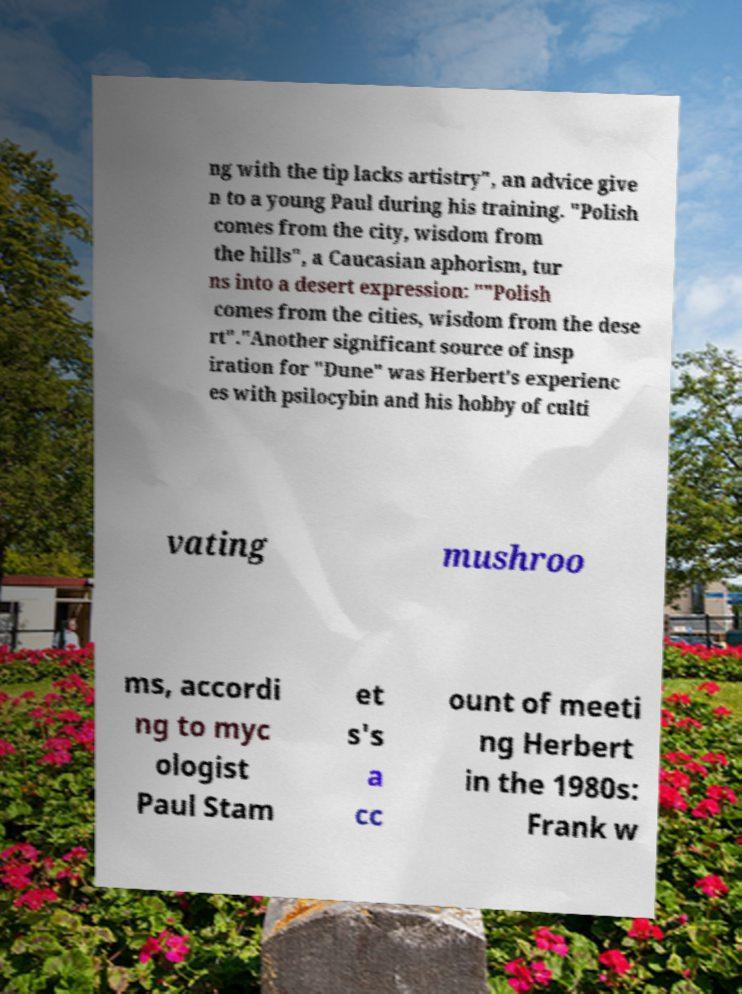Please identify and transcribe the text found in this image. ng with the tip lacks artistry", an advice give n to a young Paul during his training. "Polish comes from the city, wisdom from the hills", a Caucasian aphorism, tur ns into a desert expression: ""Polish comes from the cities, wisdom from the dese rt"."Another significant source of insp iration for "Dune" was Herbert's experienc es with psilocybin and his hobby of culti vating mushroo ms, accordi ng to myc ologist Paul Stam et s's a cc ount of meeti ng Herbert in the 1980s: Frank w 